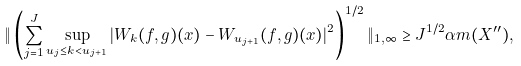Convert formula to latex. <formula><loc_0><loc_0><loc_500><loc_500>\| \left ( \sum _ { j = 1 } ^ { J } \sup _ { u _ { j } \leq k < u _ { j + 1 } } | W _ { k } ( f , g ) ( x ) - W _ { u _ { j + 1 } } ( f , g ) ( x ) | ^ { 2 } \right ) ^ { 1 / 2 } \| _ { 1 , \infty } \geq J ^ { 1 / 2 } \alpha m ( X ^ { \prime \prime } ) ,</formula> 